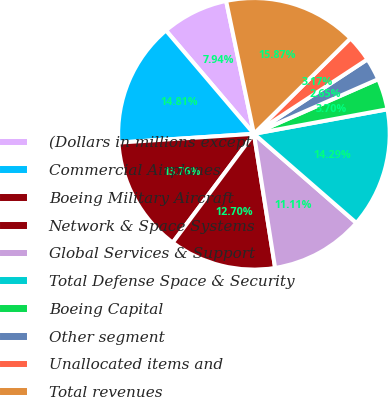<chart> <loc_0><loc_0><loc_500><loc_500><pie_chart><fcel>(Dollars in millions except<fcel>Commercial Airplanes<fcel>Boeing Military Aircraft<fcel>Network & Space Systems<fcel>Global Services & Support<fcel>Total Defense Space & Security<fcel>Boeing Capital<fcel>Other segment<fcel>Unallocated items and<fcel>Total revenues<nl><fcel>7.94%<fcel>14.81%<fcel>13.76%<fcel>12.7%<fcel>11.11%<fcel>14.29%<fcel>3.7%<fcel>2.65%<fcel>3.17%<fcel>15.87%<nl></chart> 